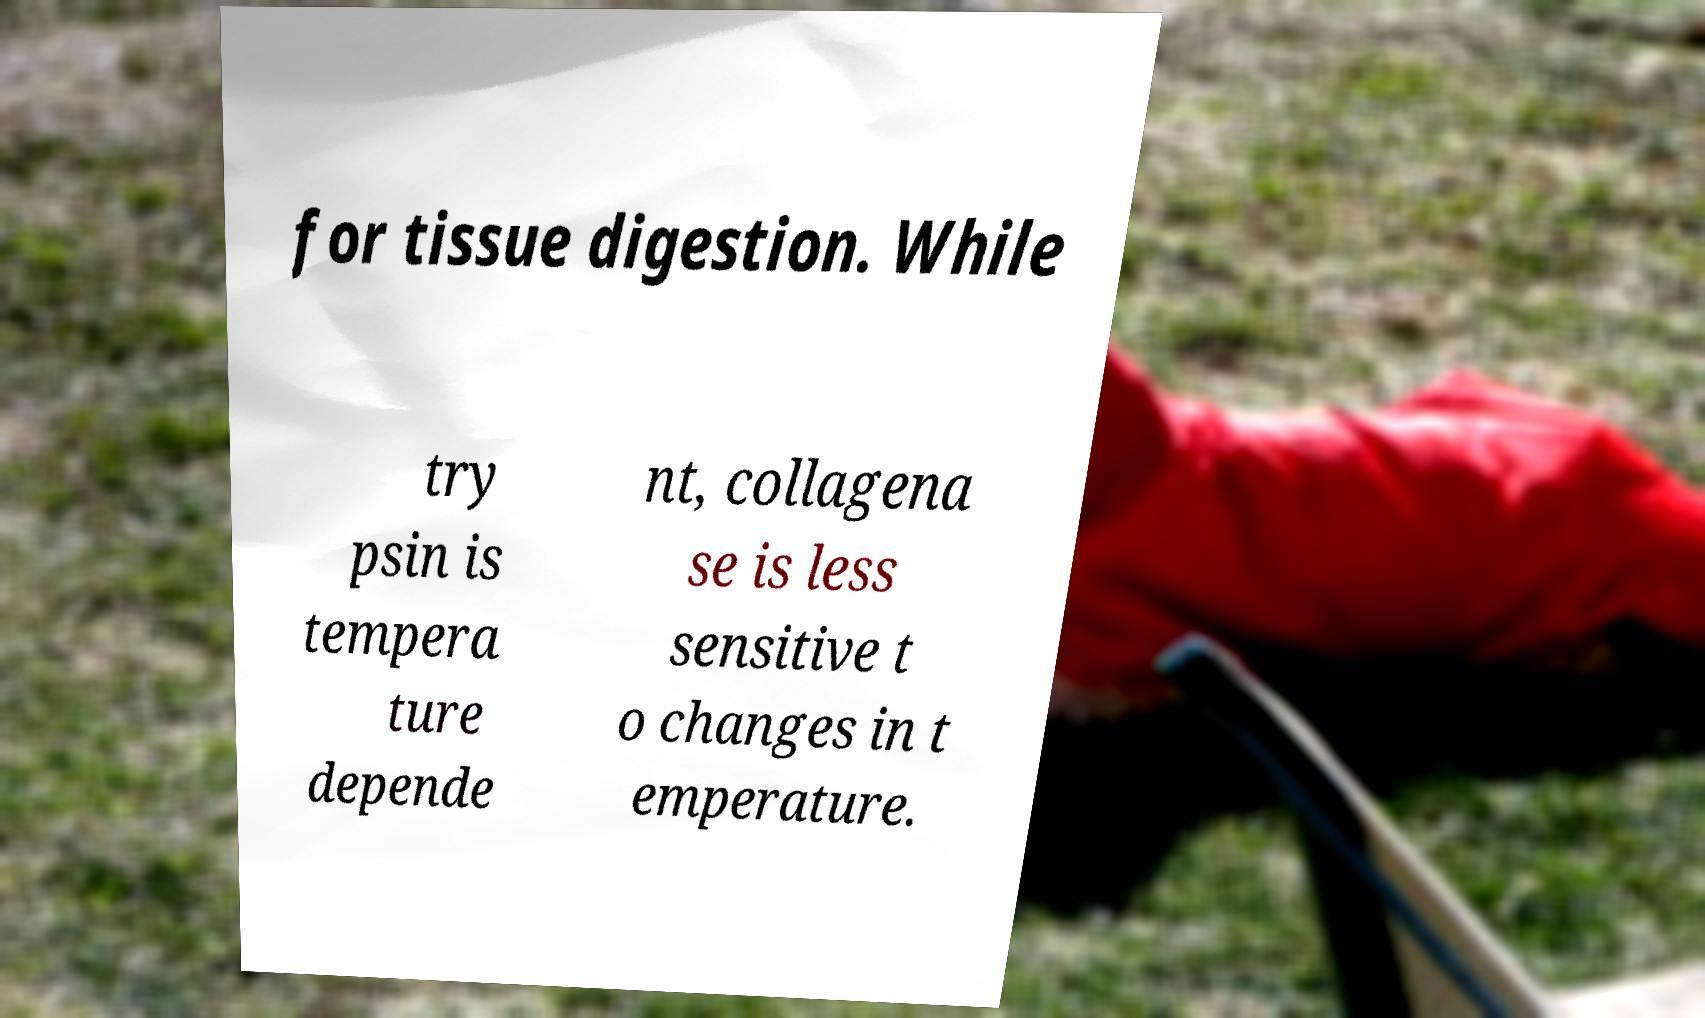I need the written content from this picture converted into text. Can you do that? for tissue digestion. While try psin is tempera ture depende nt, collagena se is less sensitive t o changes in t emperature. 